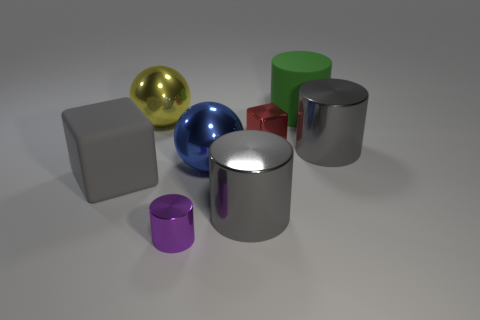Subtract all cyan balls. How many gray cylinders are left? 2 Subtract all big cylinders. How many cylinders are left? 1 Subtract all purple cylinders. How many cylinders are left? 3 Add 2 yellow spheres. How many objects exist? 10 Subtract all blue cylinders. Subtract all gray blocks. How many cylinders are left? 4 Subtract all cubes. How many objects are left? 6 Add 6 big cyan metal objects. How many big cyan metal objects exist? 6 Subtract 0 purple blocks. How many objects are left? 8 Subtract all cyan rubber cubes. Subtract all big blue metallic objects. How many objects are left? 7 Add 1 tiny red metallic things. How many tiny red metallic things are left? 2 